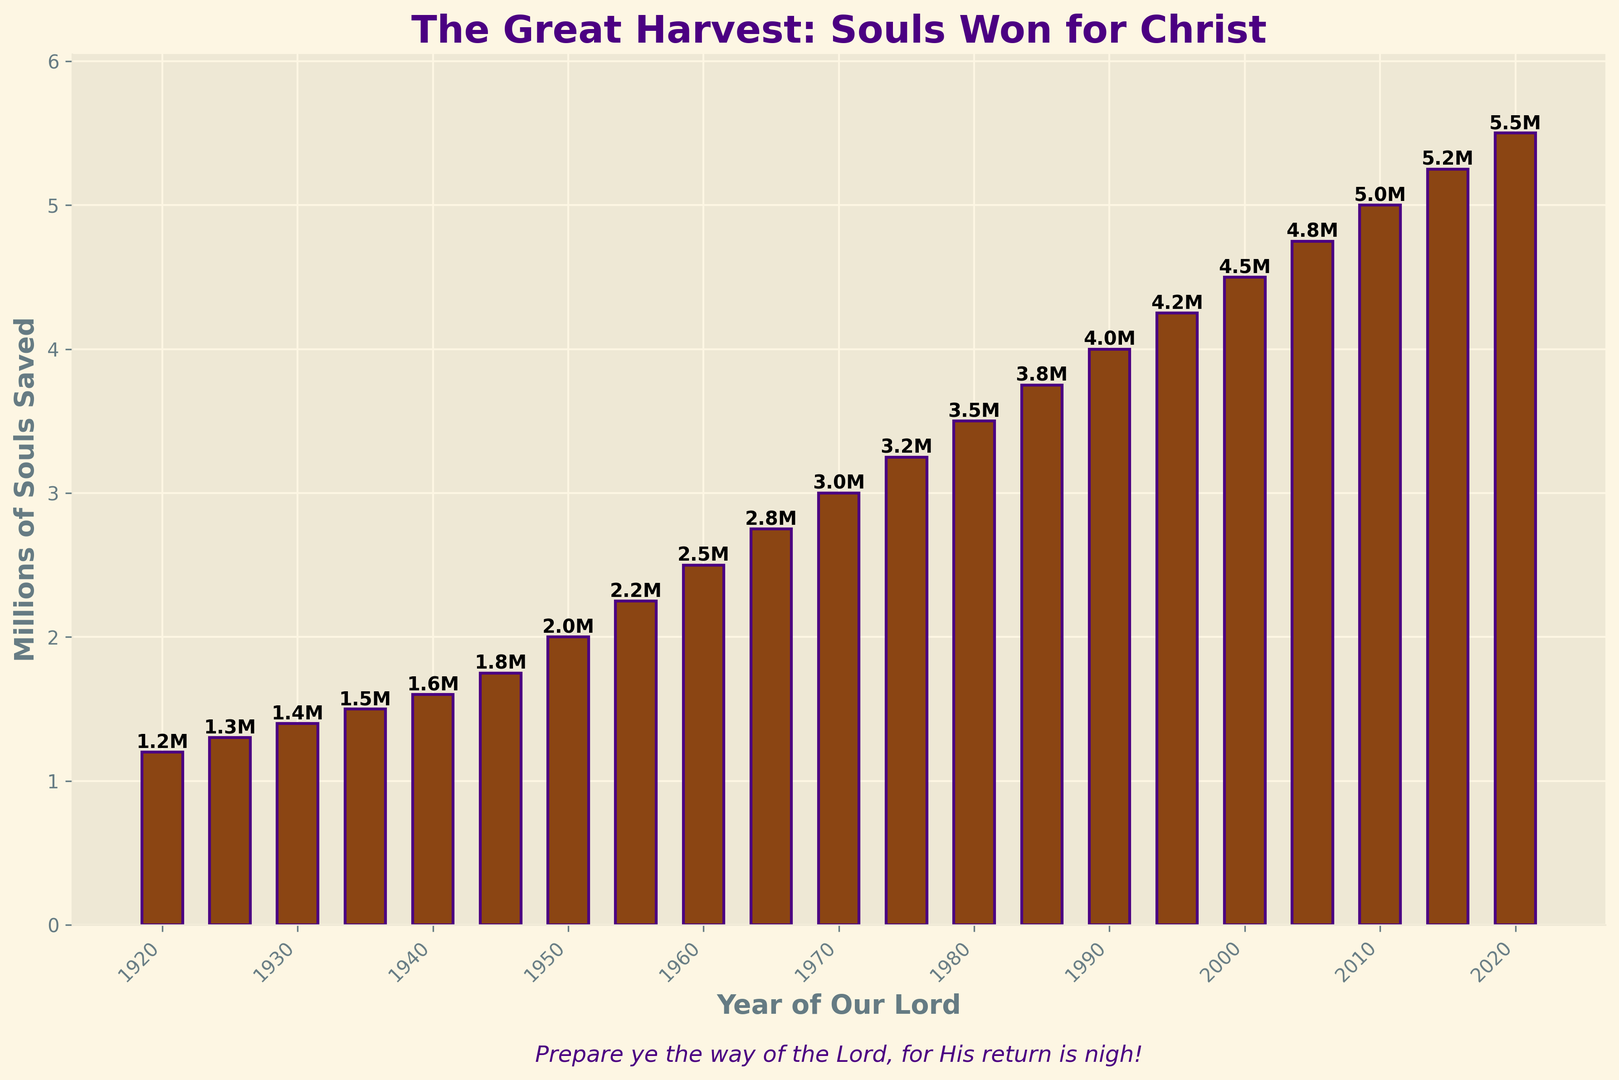How much did the number of converts increase from 1920 to 1950? In 1920 there were 1.2 million converts, and in 1950, there were 2.0 million. The difference is 2.0 million - 1.2 million = 0.8 million converts
Answer: 0.8 million In which decade did the largest increase in the number of converts occur? By comparing the increases every decade: 1920-1930 (0.2 million), 1930-1940 (0.2 million), 1940-1950 (0.4 million), 1950-1960 (0.5 million), 1960-1970 (0.5 million), 1970-1980 (0.5 million), 1980-1990 (0.5 million), 1990-2000 (0.5 million), 2000-2010 (0.5 million), and 2010-2020 (0.5 million), one sees that 1940-1950 had the largest increase
Answer: 1940-1950 How many millions of souls were saved in 1980? Look at the bar for 1980, and read its height. It represents 3.5 million converts
Answer: 3.5 million Between which consecutive decades is the increase in the number of converts the smallest? Compare each decade's increase: 1920-1930 (0.2 million), 1930-1940 (0.2 million), 1940-1950 (0.4 million), 1950-1960 (0.5 million), 1960-1970 (0.5 million), 1970-1980 (0.5 million), 1980-1990 (0.5 million), 1990-2000 (0.5 million), 2000-2010 (0.5 million), and 2010-2020 (0.5 million). The smallest increase is 1920-1930 and 1930-1940
Answer: 1920-1930 and 1930-1940 What is the ratio of the number of converts in 2020 to those in 1920? Dividing the 2020 converts (5.5 million) by the 1920 converts (1.2 million) gives 5.5 / 1.2 = approximately 4.58
Answer: 4.58 In which year did the number of converts reach 4 million? Locate the bar where the height reaches 4 million, which is in the year 1990
Answer: 1990 What is the average number of converts per year from 2000 to 2020? Sum the converts from 2000 (4.5 million), 2005 (4.75 million), 2010 (5.0 million), 2015 (5.25 million), and 2020 (5.5 million); then divide by 5. (4.5 + 4.75 + 5.0 + 5.25 + 5.5) / 5 ≈ 5.0 million
Answer: 5.0 million Identify the time period with the most consistent growth rate in terms of number of converts. From the data, the most consistent growth rate is from 1950 to 2020, with each decade showing approximately similar increases of 0.5 million converts
Answer: 1950-2020 